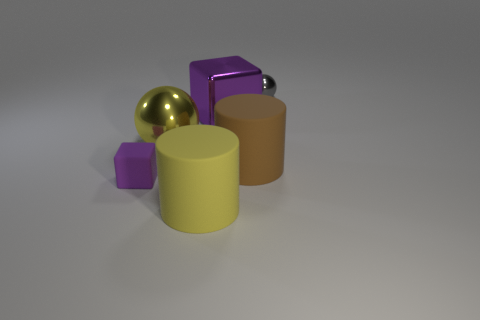Add 3 small gray shiny things. How many objects exist? 9 Subtract all spheres. How many objects are left? 4 Subtract all large yellow matte cylinders. Subtract all big blue shiny cylinders. How many objects are left? 5 Add 6 big brown matte objects. How many big brown matte objects are left? 7 Add 4 yellow spheres. How many yellow spheres exist? 5 Subtract 0 purple spheres. How many objects are left? 6 